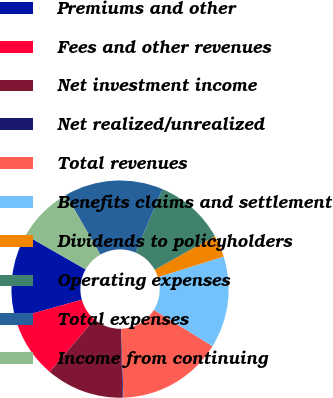Convert chart. <chart><loc_0><loc_0><loc_500><loc_500><pie_chart><fcel>Premiums and other<fcel>Fees and other revenues<fcel>Net investment income<fcel>Net realized/unrealized<fcel>Total revenues<fcel>Benefits claims and settlement<fcel>Dividends to policyholders<fcel>Operating expenses<fcel>Total expenses<fcel>Income from continuing<nl><fcel>12.6%<fcel>9.48%<fcel>11.56%<fcel>0.13%<fcel>15.71%<fcel>13.64%<fcel>3.25%<fcel>10.52%<fcel>14.67%<fcel>8.44%<nl></chart> 